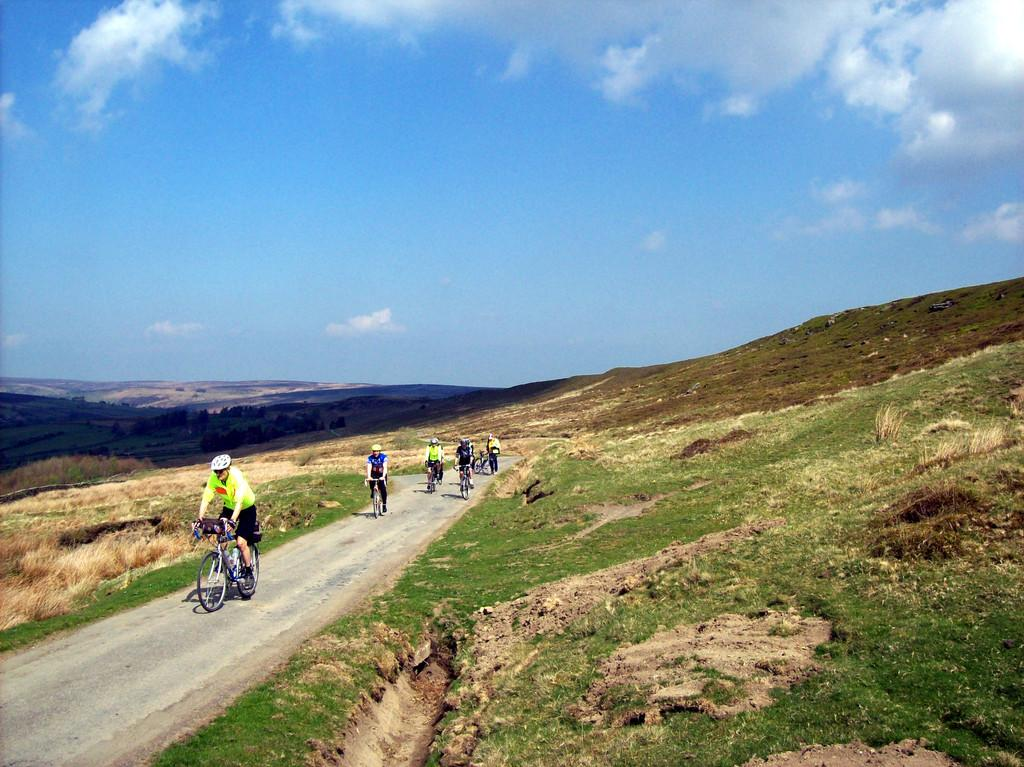What type of landscape can be seen in the image? There are hills in the image. What are the people in the image doing? The people in the image are on cycles. What can be seen on the ground in the image? There is a path visible in the image. What is the condition of the sky in the sky in the image? The sky is clear in the background of the image. What type of poison is being distributed by the people on cycles in the image? There is no mention of poison or distribution in the image; the people are simply cycling on a path. 